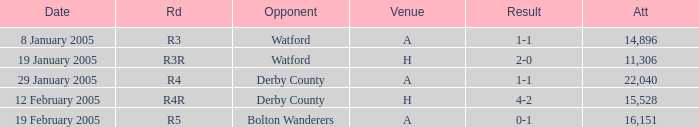What is the date where the round is R3? 8 January 2005. 